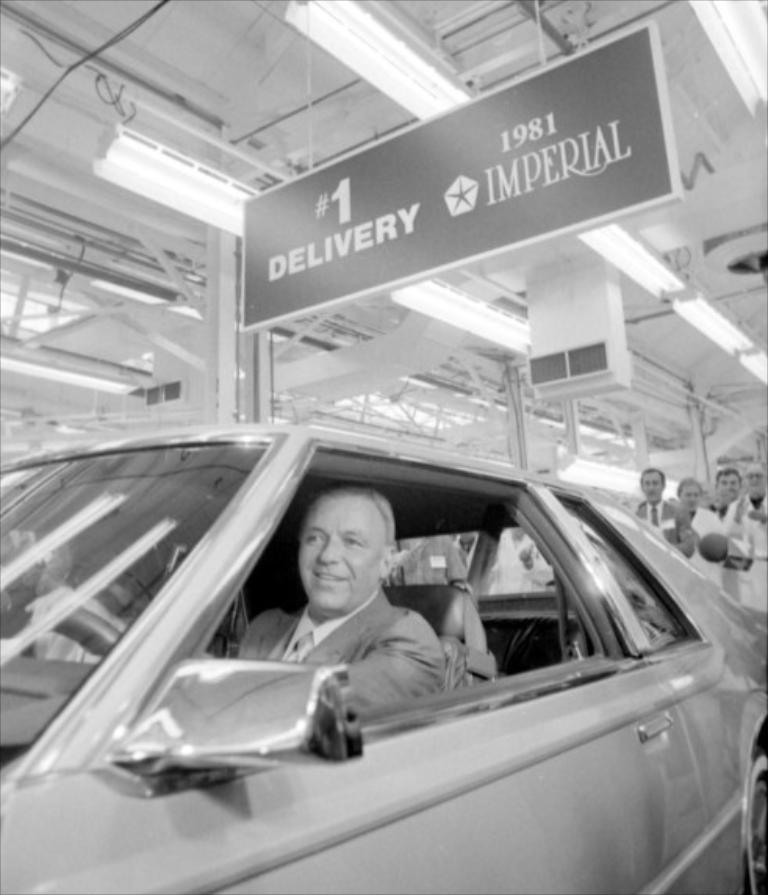What is the main subject of the image? There is a vehicle in the image. Can you describe the person inside the vehicle? A person is sitting inside the vehicle. What else can be seen in the image besides the vehicle and the person inside it? There are other people visible behind the vehicle. What is the chance of the person in the vehicle winning the market competition? There is no information about a market competition or any chance of winning in the image, so it cannot be determined. 